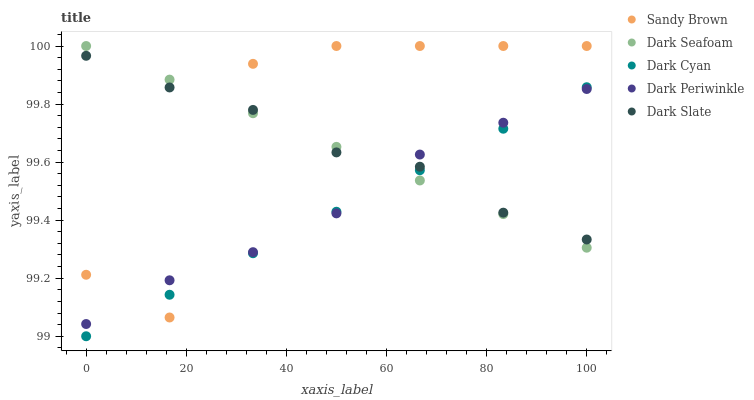Does Dark Cyan have the minimum area under the curve?
Answer yes or no. Yes. Does Sandy Brown have the maximum area under the curve?
Answer yes or no. Yes. Does Dark Slate have the minimum area under the curve?
Answer yes or no. No. Does Dark Slate have the maximum area under the curve?
Answer yes or no. No. Is Dark Cyan the smoothest?
Answer yes or no. Yes. Is Sandy Brown the roughest?
Answer yes or no. Yes. Is Dark Slate the smoothest?
Answer yes or no. No. Is Dark Slate the roughest?
Answer yes or no. No. Does Dark Cyan have the lowest value?
Answer yes or no. Yes. Does Dark Seafoam have the lowest value?
Answer yes or no. No. Does Sandy Brown have the highest value?
Answer yes or no. Yes. Does Dark Slate have the highest value?
Answer yes or no. No. Does Dark Slate intersect Dark Seafoam?
Answer yes or no. Yes. Is Dark Slate less than Dark Seafoam?
Answer yes or no. No. Is Dark Slate greater than Dark Seafoam?
Answer yes or no. No. 